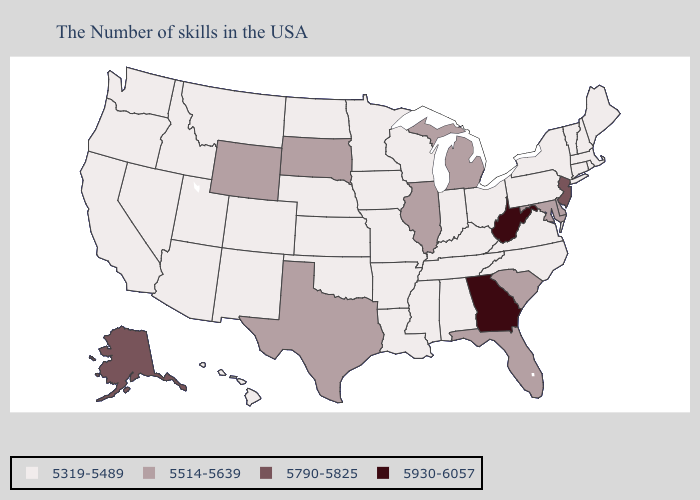What is the value of Missouri?
Concise answer only. 5319-5489. Among the states that border Kansas , which have the lowest value?
Give a very brief answer. Missouri, Nebraska, Oklahoma, Colorado. What is the value of North Dakota?
Answer briefly. 5319-5489. Among the states that border Wisconsin , which have the lowest value?
Be succinct. Minnesota, Iowa. Does Indiana have the same value as New Jersey?
Answer briefly. No. What is the lowest value in the USA?
Short answer required. 5319-5489. Which states have the highest value in the USA?
Short answer required. West Virginia, Georgia. What is the value of New York?
Give a very brief answer. 5319-5489. Does Connecticut have a lower value than Rhode Island?
Write a very short answer. No. Among the states that border Pennsylvania , does New York have the lowest value?
Concise answer only. Yes. Name the states that have a value in the range 5514-5639?
Quick response, please. Delaware, Maryland, South Carolina, Florida, Michigan, Illinois, Texas, South Dakota, Wyoming. What is the value of Massachusetts?
Write a very short answer. 5319-5489. Which states have the lowest value in the Northeast?
Answer briefly. Maine, Massachusetts, Rhode Island, New Hampshire, Vermont, Connecticut, New York, Pennsylvania. Does Texas have the lowest value in the USA?
Short answer required. No. Among the states that border New Mexico , does Oklahoma have the lowest value?
Keep it brief. Yes. 